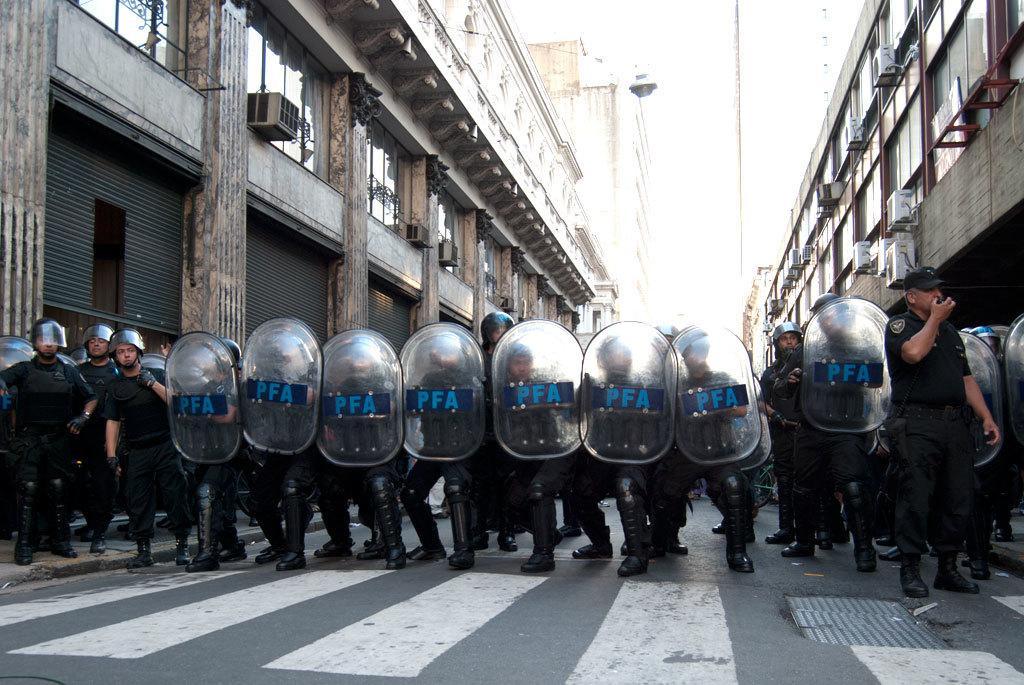Can you describe this image briefly? In this image, we can see people holding shields in their hands. In the background, there are buildings and at the bottom, there is road. 